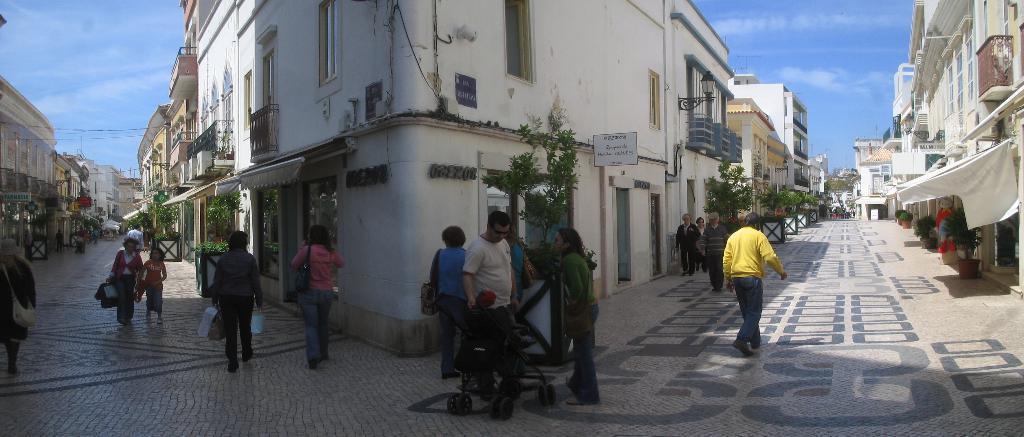Can you describe this image briefly? In this image in the middle there are people, some are walking, some are standing and there are buildings, tents, windows, plants, posters. On the right there is a man, he is walking and there is a floor. In the background there are sky and clouds. 